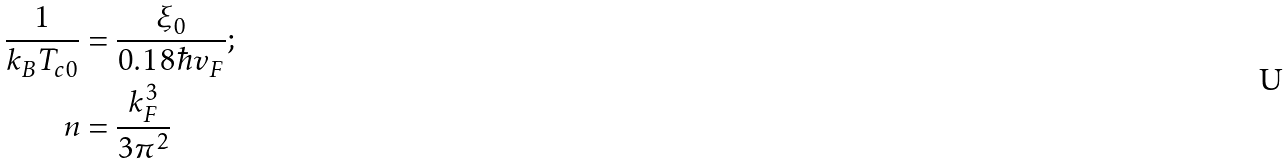Convert formula to latex. <formula><loc_0><loc_0><loc_500><loc_500>\frac { 1 } { k _ { B } T _ { c 0 } } & = \frac { \xi _ { 0 } } { 0 . 1 8 \hbar { v } _ { F } } ; \\ n & = \frac { k _ { F } ^ { 3 } } { 3 \pi ^ { 2 } }</formula> 